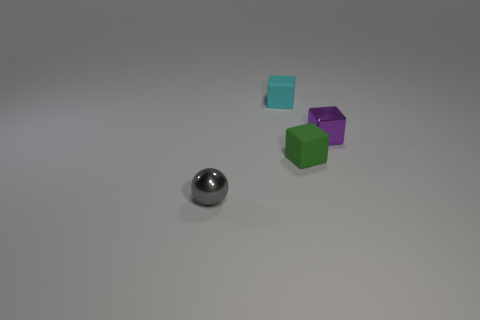There is a small shiny thing behind the tiny metallic thing that is in front of the small purple thing; how many gray shiny objects are right of it?
Your response must be concise. 0. Is there any other thing that has the same shape as the tiny gray metallic thing?
Offer a terse response. No. How many things are cyan shiny cylinders or tiny purple shiny things?
Provide a short and direct response. 1. There is a cyan rubber object; is its shape the same as the metallic object that is behind the gray object?
Offer a very short reply. Yes. There is a small metal object that is in front of the small green matte object; what shape is it?
Your response must be concise. Sphere. Does the green rubber thing have the same shape as the cyan matte thing?
Ensure brevity in your answer.  Yes. There is a rubber thing that is in front of the purple object; is it the same size as the tiny gray metallic sphere?
Ensure brevity in your answer.  Yes. What number of shiny objects have the same color as the sphere?
Your answer should be very brief. 0. Are there an equal number of green matte blocks on the right side of the small green block and small cyan matte objects?
Provide a short and direct response. No. The small shiny ball has what color?
Make the answer very short. Gray. 